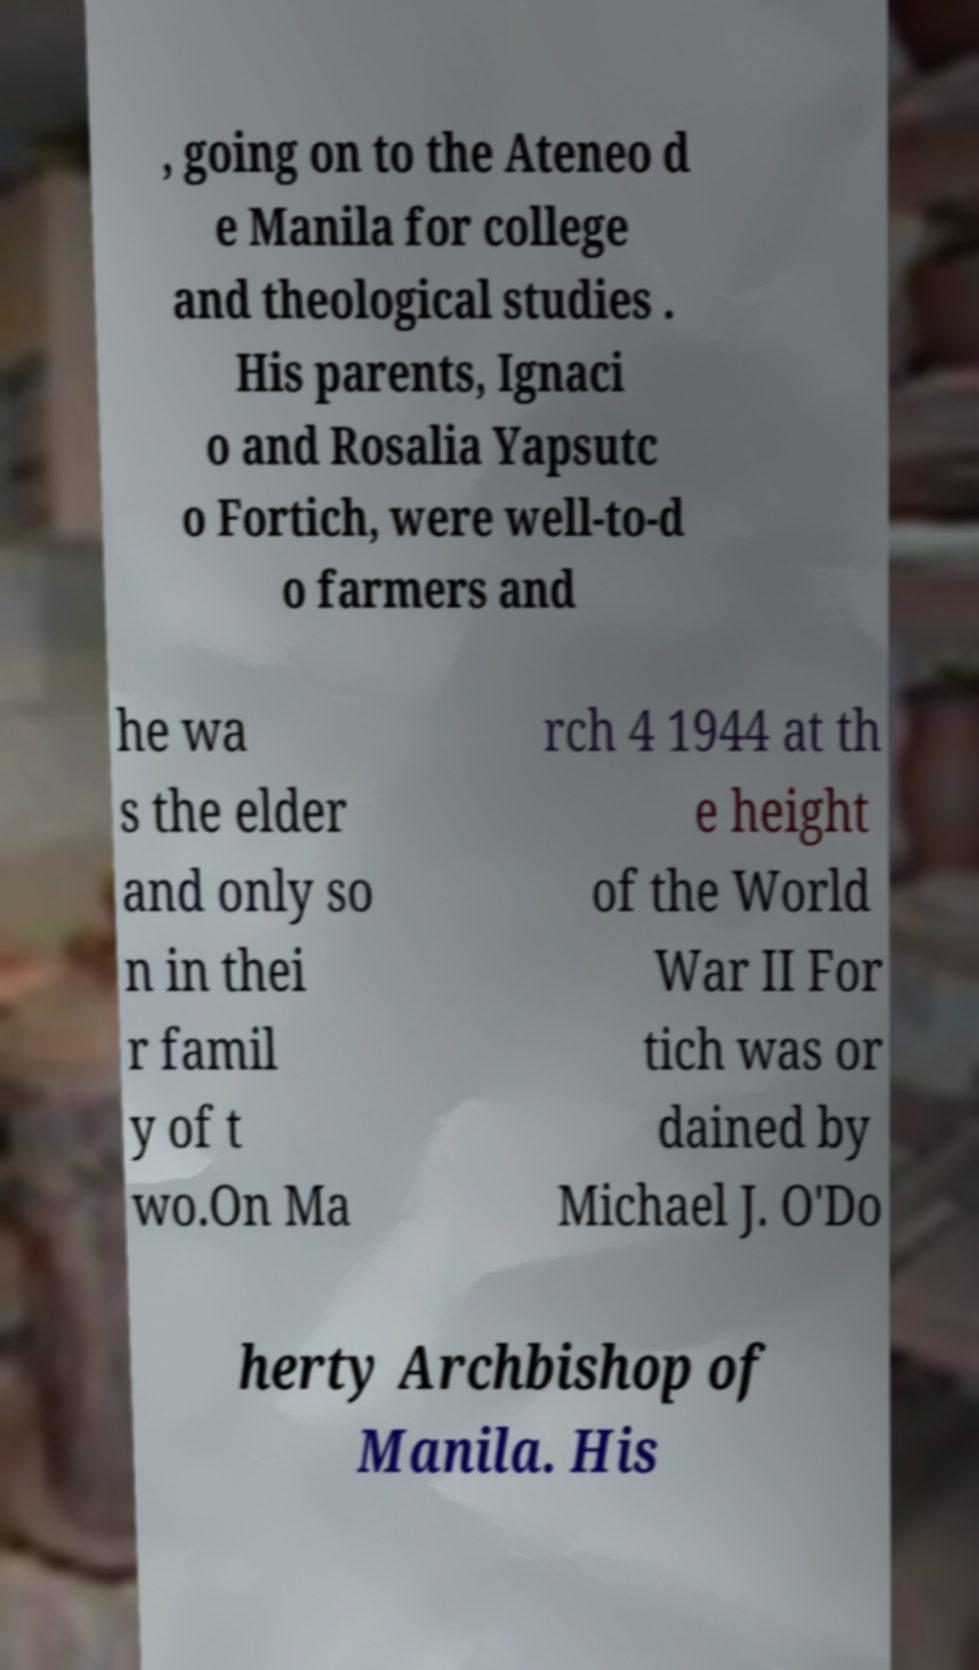There's text embedded in this image that I need extracted. Can you transcribe it verbatim? , going on to the Ateneo d e Manila for college and theological studies . His parents, Ignaci o and Rosalia Yapsutc o Fortich, were well-to-d o farmers and he wa s the elder and only so n in thei r famil y of t wo.On Ma rch 4 1944 at th e height of the World War II For tich was or dained by Michael J. O'Do herty Archbishop of Manila. His 